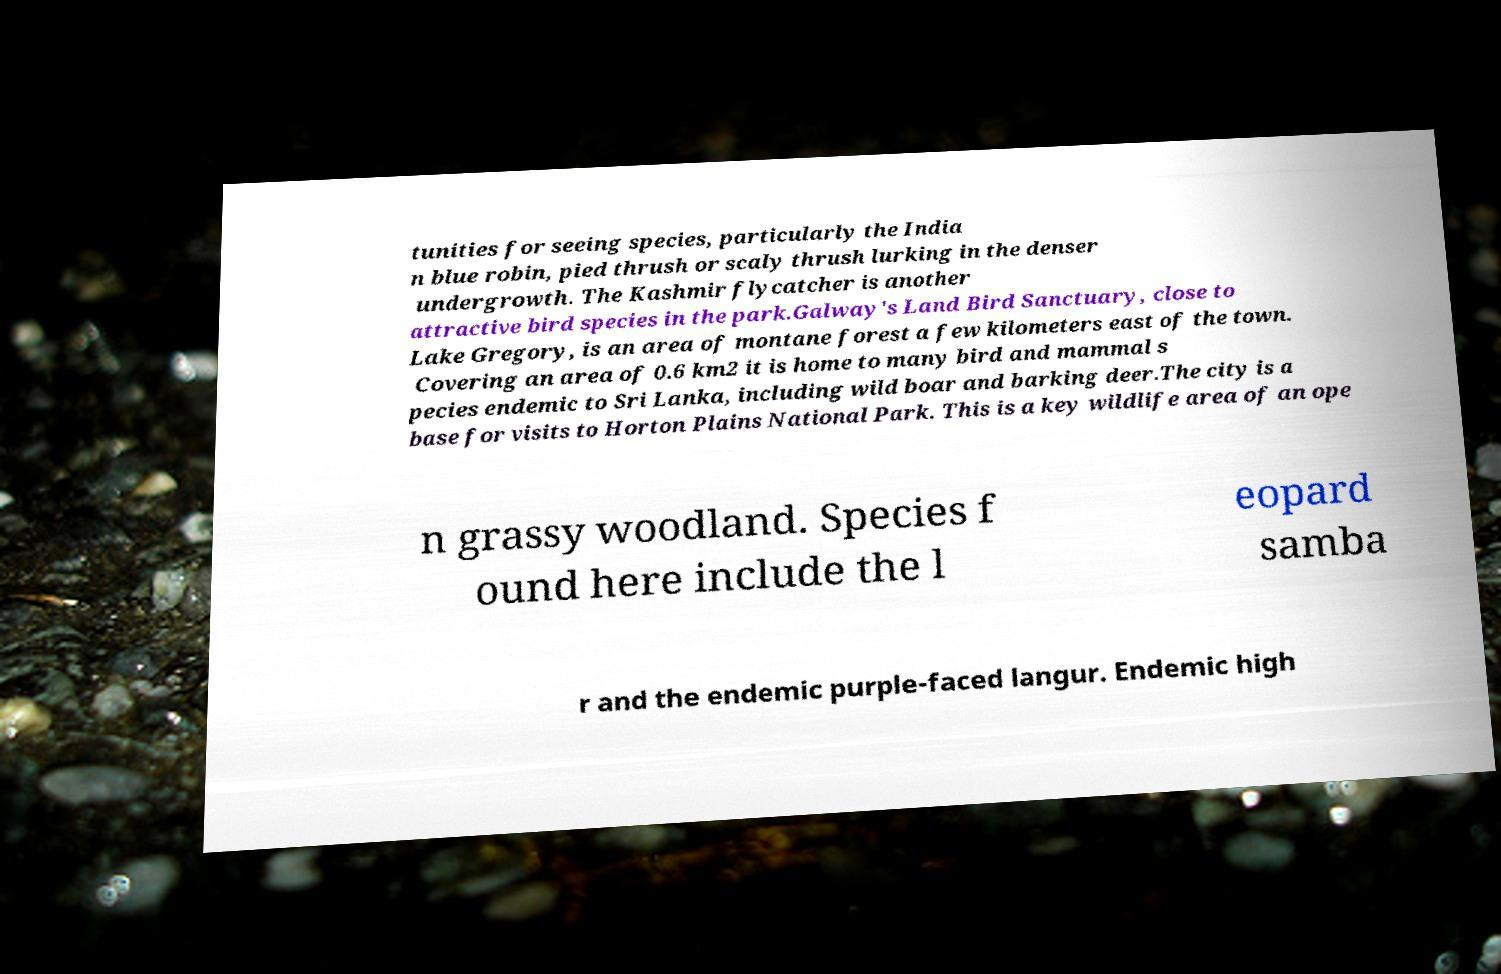What messages or text are displayed in this image? I need them in a readable, typed format. tunities for seeing species, particularly the India n blue robin, pied thrush or scaly thrush lurking in the denser undergrowth. The Kashmir flycatcher is another attractive bird species in the park.Galway's Land Bird Sanctuary, close to Lake Gregory, is an area of montane forest a few kilometers east of the town. Covering an area of 0.6 km2 it is home to many bird and mammal s pecies endemic to Sri Lanka, including wild boar and barking deer.The city is a base for visits to Horton Plains National Park. This is a key wildlife area of an ope n grassy woodland. Species f ound here include the l eopard samba r and the endemic purple-faced langur. Endemic high 